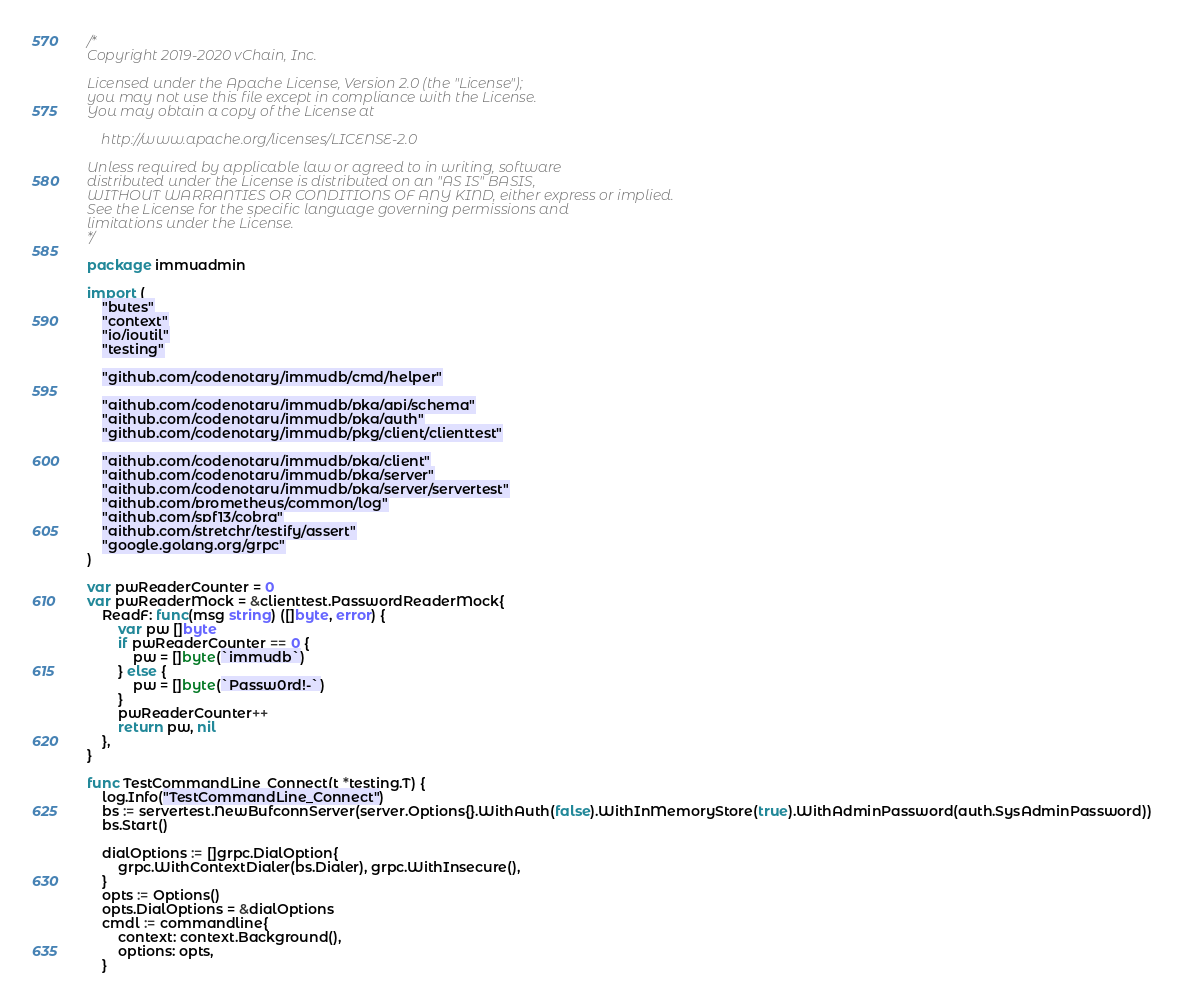<code> <loc_0><loc_0><loc_500><loc_500><_Go_>/*
Copyright 2019-2020 vChain, Inc.

Licensed under the Apache License, Version 2.0 (the "License");
you may not use this file except in compliance with the License.
You may obtain a copy of the License at

	http://www.apache.org/licenses/LICENSE-2.0

Unless required by applicable law or agreed to in writing, software
distributed under the License is distributed on an "AS IS" BASIS,
WITHOUT WARRANTIES OR CONDITIONS OF ANY KIND, either express or implied.
See the License for the specific language governing permissions and
limitations under the License.
*/

package immuadmin

import (
	"bytes"
	"context"
	"io/ioutil"
	"testing"

	"github.com/codenotary/immudb/cmd/helper"

	"github.com/codenotary/immudb/pkg/api/schema"
	"github.com/codenotary/immudb/pkg/auth"
	"github.com/codenotary/immudb/pkg/client/clienttest"

	"github.com/codenotary/immudb/pkg/client"
	"github.com/codenotary/immudb/pkg/server"
	"github.com/codenotary/immudb/pkg/server/servertest"
	"github.com/prometheus/common/log"
	"github.com/spf13/cobra"
	"github.com/stretchr/testify/assert"
	"google.golang.org/grpc"
)

var pwReaderCounter = 0
var pwReaderMock = &clienttest.PasswordReaderMock{
	ReadF: func(msg string) ([]byte, error) {
		var pw []byte
		if pwReaderCounter == 0 {
			pw = []byte(`immudb`)
		} else {
			pw = []byte(`Passw0rd!-`)
		}
		pwReaderCounter++
		return pw, nil
	},
}

func TestCommandLine_Connect(t *testing.T) {
	log.Info("TestCommandLine_Connect")
	bs := servertest.NewBufconnServer(server.Options{}.WithAuth(false).WithInMemoryStore(true).WithAdminPassword(auth.SysAdminPassword))
	bs.Start()

	dialOptions := []grpc.DialOption{
		grpc.WithContextDialer(bs.Dialer), grpc.WithInsecure(),
	}
	opts := Options()
	opts.DialOptions = &dialOptions
	cmdl := commandline{
		context: context.Background(),
		options: opts,
	}</code> 